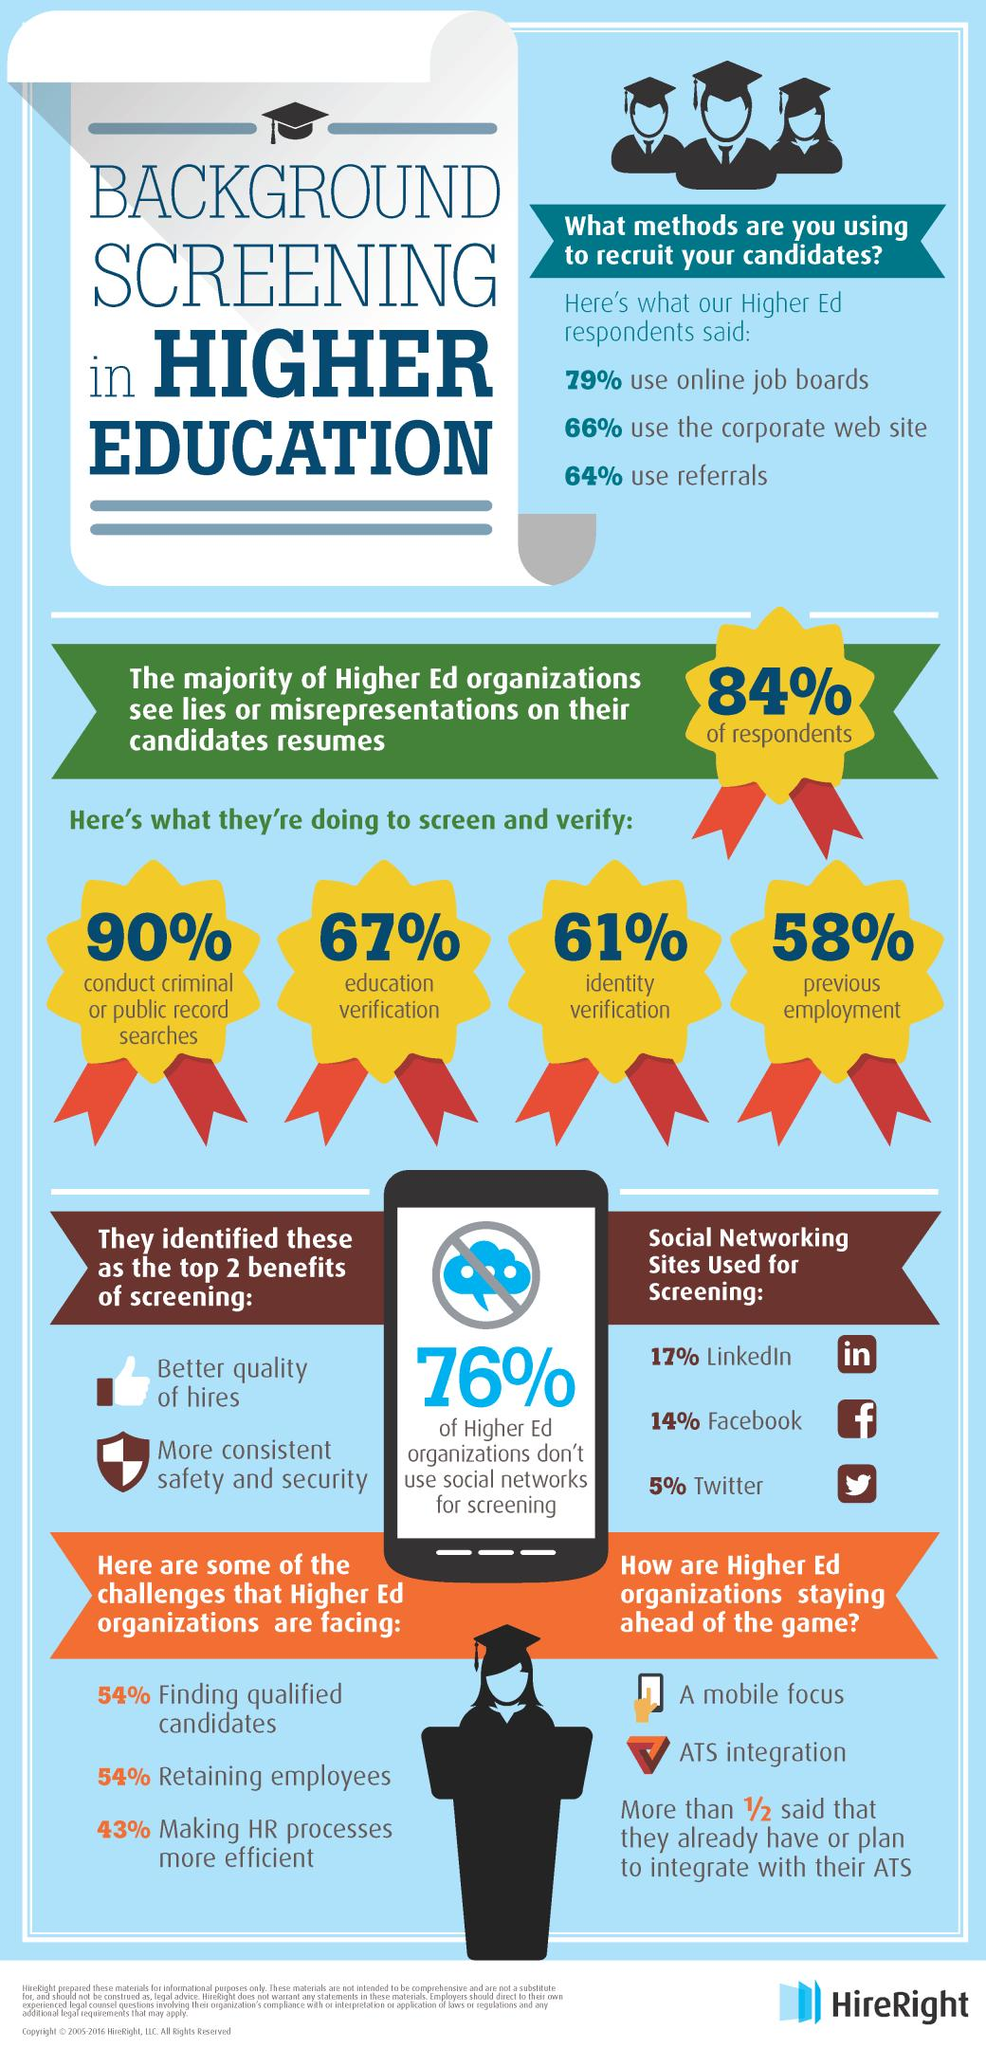Mention a couple of crucial points in this snapshot. Better quality of hires can be obtained through screening methods that involve rigorous evaluation and assessment of job candidates to ensure that they possess the necessary skills, qualifications, and character traits required for the position. The second most commonly used method for recruiting candidates is through the corporate website. LinkedIn is the social networking site that is most widely used by recruiters. A large majority of recruiters, approximately 90%, conduct criminal or public record searches as part of their hiring process. A large majority of recruiters, at 67%, conduct education verification as part of their hiring process. 